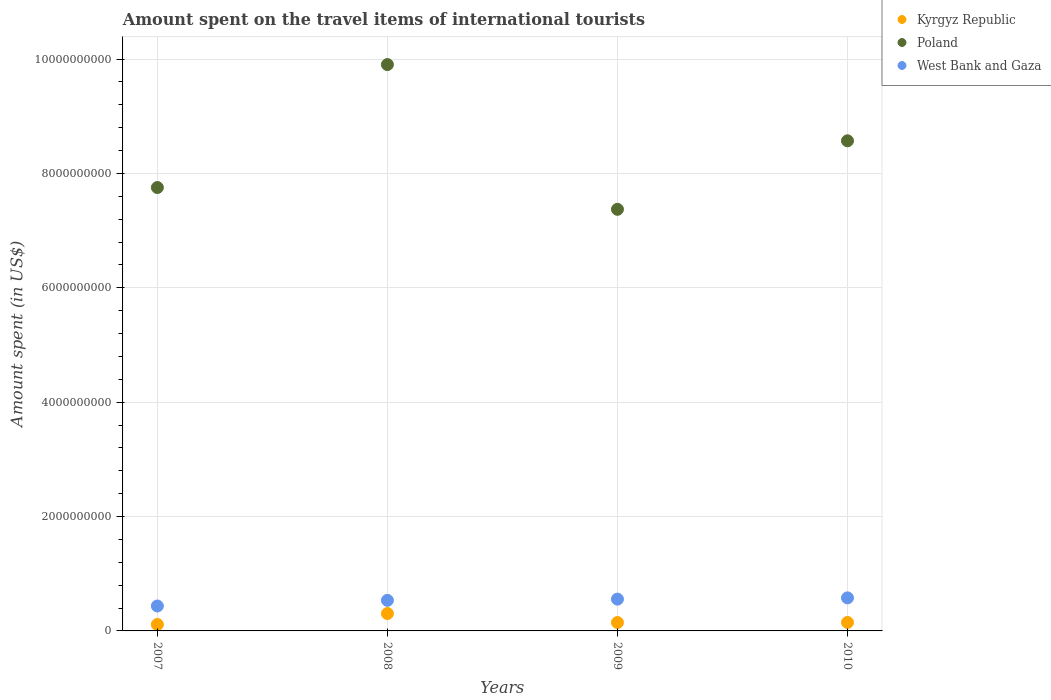How many different coloured dotlines are there?
Offer a terse response. 3. Is the number of dotlines equal to the number of legend labels?
Your answer should be compact. Yes. What is the amount spent on the travel items of international tourists in West Bank and Gaza in 2008?
Offer a terse response. 5.35e+08. Across all years, what is the maximum amount spent on the travel items of international tourists in Kyrgyz Republic?
Give a very brief answer. 3.04e+08. Across all years, what is the minimum amount spent on the travel items of international tourists in West Bank and Gaza?
Keep it short and to the point. 4.36e+08. What is the total amount spent on the travel items of international tourists in Kyrgyz Republic in the graph?
Offer a terse response. 7.11e+08. What is the difference between the amount spent on the travel items of international tourists in Poland in 2009 and that in 2010?
Make the answer very short. -1.20e+09. What is the difference between the amount spent on the travel items of international tourists in Poland in 2008 and the amount spent on the travel items of international tourists in Kyrgyz Republic in 2007?
Your answer should be very brief. 9.79e+09. What is the average amount spent on the travel items of international tourists in Kyrgyz Republic per year?
Your answer should be compact. 1.78e+08. In the year 2009, what is the difference between the amount spent on the travel items of international tourists in West Bank and Gaza and amount spent on the travel items of international tourists in Poland?
Offer a very short reply. -6.82e+09. What is the ratio of the amount spent on the travel items of international tourists in Kyrgyz Republic in 2008 to that in 2010?
Your answer should be very brief. 2.05. Is the difference between the amount spent on the travel items of international tourists in West Bank and Gaza in 2008 and 2010 greater than the difference between the amount spent on the travel items of international tourists in Poland in 2008 and 2010?
Provide a succinct answer. No. What is the difference between the highest and the second highest amount spent on the travel items of international tourists in Poland?
Ensure brevity in your answer.  1.33e+09. What is the difference between the highest and the lowest amount spent on the travel items of international tourists in West Bank and Gaza?
Give a very brief answer. 1.42e+08. Is the amount spent on the travel items of international tourists in Kyrgyz Republic strictly greater than the amount spent on the travel items of international tourists in Poland over the years?
Offer a terse response. No. Is the amount spent on the travel items of international tourists in West Bank and Gaza strictly less than the amount spent on the travel items of international tourists in Kyrgyz Republic over the years?
Provide a succinct answer. No. What is the difference between two consecutive major ticks on the Y-axis?
Provide a short and direct response. 2.00e+09. Does the graph contain grids?
Your answer should be compact. Yes. Where does the legend appear in the graph?
Your answer should be compact. Top right. How many legend labels are there?
Your response must be concise. 3. How are the legend labels stacked?
Offer a terse response. Vertical. What is the title of the graph?
Offer a very short reply. Amount spent on the travel items of international tourists. What is the label or title of the Y-axis?
Ensure brevity in your answer.  Amount spent (in US$). What is the Amount spent (in US$) of Kyrgyz Republic in 2007?
Ensure brevity in your answer.  1.12e+08. What is the Amount spent (in US$) in Poland in 2007?
Your answer should be very brief. 7.75e+09. What is the Amount spent (in US$) of West Bank and Gaza in 2007?
Provide a succinct answer. 4.36e+08. What is the Amount spent (in US$) in Kyrgyz Republic in 2008?
Provide a short and direct response. 3.04e+08. What is the Amount spent (in US$) in Poland in 2008?
Your response must be concise. 9.90e+09. What is the Amount spent (in US$) in West Bank and Gaza in 2008?
Make the answer very short. 5.35e+08. What is the Amount spent (in US$) of Kyrgyz Republic in 2009?
Give a very brief answer. 1.47e+08. What is the Amount spent (in US$) of Poland in 2009?
Ensure brevity in your answer.  7.37e+09. What is the Amount spent (in US$) in West Bank and Gaza in 2009?
Your answer should be compact. 5.56e+08. What is the Amount spent (in US$) in Kyrgyz Republic in 2010?
Your answer should be very brief. 1.48e+08. What is the Amount spent (in US$) in Poland in 2010?
Make the answer very short. 8.57e+09. What is the Amount spent (in US$) of West Bank and Gaza in 2010?
Your response must be concise. 5.78e+08. Across all years, what is the maximum Amount spent (in US$) in Kyrgyz Republic?
Make the answer very short. 3.04e+08. Across all years, what is the maximum Amount spent (in US$) of Poland?
Offer a terse response. 9.90e+09. Across all years, what is the maximum Amount spent (in US$) in West Bank and Gaza?
Your answer should be compact. 5.78e+08. Across all years, what is the minimum Amount spent (in US$) in Kyrgyz Republic?
Ensure brevity in your answer.  1.12e+08. Across all years, what is the minimum Amount spent (in US$) of Poland?
Your answer should be compact. 7.37e+09. Across all years, what is the minimum Amount spent (in US$) of West Bank and Gaza?
Make the answer very short. 4.36e+08. What is the total Amount spent (in US$) in Kyrgyz Republic in the graph?
Give a very brief answer. 7.11e+08. What is the total Amount spent (in US$) in Poland in the graph?
Provide a short and direct response. 3.36e+1. What is the total Amount spent (in US$) of West Bank and Gaza in the graph?
Offer a very short reply. 2.10e+09. What is the difference between the Amount spent (in US$) in Kyrgyz Republic in 2007 and that in 2008?
Ensure brevity in your answer.  -1.92e+08. What is the difference between the Amount spent (in US$) in Poland in 2007 and that in 2008?
Provide a succinct answer. -2.15e+09. What is the difference between the Amount spent (in US$) of West Bank and Gaza in 2007 and that in 2008?
Provide a short and direct response. -9.90e+07. What is the difference between the Amount spent (in US$) in Kyrgyz Republic in 2007 and that in 2009?
Your answer should be very brief. -3.50e+07. What is the difference between the Amount spent (in US$) of Poland in 2007 and that in 2009?
Provide a succinct answer. 3.81e+08. What is the difference between the Amount spent (in US$) of West Bank and Gaza in 2007 and that in 2009?
Offer a terse response. -1.20e+08. What is the difference between the Amount spent (in US$) in Kyrgyz Republic in 2007 and that in 2010?
Ensure brevity in your answer.  -3.60e+07. What is the difference between the Amount spent (in US$) of Poland in 2007 and that in 2010?
Keep it short and to the point. -8.17e+08. What is the difference between the Amount spent (in US$) in West Bank and Gaza in 2007 and that in 2010?
Ensure brevity in your answer.  -1.42e+08. What is the difference between the Amount spent (in US$) of Kyrgyz Republic in 2008 and that in 2009?
Ensure brevity in your answer.  1.57e+08. What is the difference between the Amount spent (in US$) of Poland in 2008 and that in 2009?
Offer a very short reply. 2.53e+09. What is the difference between the Amount spent (in US$) in West Bank and Gaza in 2008 and that in 2009?
Ensure brevity in your answer.  -2.10e+07. What is the difference between the Amount spent (in US$) of Kyrgyz Republic in 2008 and that in 2010?
Keep it short and to the point. 1.56e+08. What is the difference between the Amount spent (in US$) of Poland in 2008 and that in 2010?
Provide a succinct answer. 1.33e+09. What is the difference between the Amount spent (in US$) in West Bank and Gaza in 2008 and that in 2010?
Make the answer very short. -4.30e+07. What is the difference between the Amount spent (in US$) in Poland in 2009 and that in 2010?
Your answer should be compact. -1.20e+09. What is the difference between the Amount spent (in US$) in West Bank and Gaza in 2009 and that in 2010?
Offer a terse response. -2.20e+07. What is the difference between the Amount spent (in US$) of Kyrgyz Republic in 2007 and the Amount spent (in US$) of Poland in 2008?
Offer a terse response. -9.79e+09. What is the difference between the Amount spent (in US$) in Kyrgyz Republic in 2007 and the Amount spent (in US$) in West Bank and Gaza in 2008?
Your answer should be compact. -4.23e+08. What is the difference between the Amount spent (in US$) of Poland in 2007 and the Amount spent (in US$) of West Bank and Gaza in 2008?
Provide a short and direct response. 7.22e+09. What is the difference between the Amount spent (in US$) of Kyrgyz Republic in 2007 and the Amount spent (in US$) of Poland in 2009?
Your response must be concise. -7.26e+09. What is the difference between the Amount spent (in US$) in Kyrgyz Republic in 2007 and the Amount spent (in US$) in West Bank and Gaza in 2009?
Your response must be concise. -4.44e+08. What is the difference between the Amount spent (in US$) of Poland in 2007 and the Amount spent (in US$) of West Bank and Gaza in 2009?
Provide a short and direct response. 7.20e+09. What is the difference between the Amount spent (in US$) in Kyrgyz Republic in 2007 and the Amount spent (in US$) in Poland in 2010?
Ensure brevity in your answer.  -8.46e+09. What is the difference between the Amount spent (in US$) in Kyrgyz Republic in 2007 and the Amount spent (in US$) in West Bank and Gaza in 2010?
Give a very brief answer. -4.66e+08. What is the difference between the Amount spent (in US$) in Poland in 2007 and the Amount spent (in US$) in West Bank and Gaza in 2010?
Offer a very short reply. 7.18e+09. What is the difference between the Amount spent (in US$) in Kyrgyz Republic in 2008 and the Amount spent (in US$) in Poland in 2009?
Make the answer very short. -7.07e+09. What is the difference between the Amount spent (in US$) in Kyrgyz Republic in 2008 and the Amount spent (in US$) in West Bank and Gaza in 2009?
Provide a succinct answer. -2.52e+08. What is the difference between the Amount spent (in US$) of Poland in 2008 and the Amount spent (in US$) of West Bank and Gaza in 2009?
Offer a terse response. 9.35e+09. What is the difference between the Amount spent (in US$) in Kyrgyz Republic in 2008 and the Amount spent (in US$) in Poland in 2010?
Ensure brevity in your answer.  -8.27e+09. What is the difference between the Amount spent (in US$) in Kyrgyz Republic in 2008 and the Amount spent (in US$) in West Bank and Gaza in 2010?
Offer a terse response. -2.74e+08. What is the difference between the Amount spent (in US$) of Poland in 2008 and the Amount spent (in US$) of West Bank and Gaza in 2010?
Provide a short and direct response. 9.32e+09. What is the difference between the Amount spent (in US$) in Kyrgyz Republic in 2009 and the Amount spent (in US$) in Poland in 2010?
Offer a very short reply. -8.42e+09. What is the difference between the Amount spent (in US$) of Kyrgyz Republic in 2009 and the Amount spent (in US$) of West Bank and Gaza in 2010?
Provide a succinct answer. -4.31e+08. What is the difference between the Amount spent (in US$) of Poland in 2009 and the Amount spent (in US$) of West Bank and Gaza in 2010?
Give a very brief answer. 6.79e+09. What is the average Amount spent (in US$) of Kyrgyz Republic per year?
Provide a short and direct response. 1.78e+08. What is the average Amount spent (in US$) in Poland per year?
Make the answer very short. 8.40e+09. What is the average Amount spent (in US$) of West Bank and Gaza per year?
Provide a succinct answer. 5.26e+08. In the year 2007, what is the difference between the Amount spent (in US$) in Kyrgyz Republic and Amount spent (in US$) in Poland?
Offer a very short reply. -7.64e+09. In the year 2007, what is the difference between the Amount spent (in US$) of Kyrgyz Republic and Amount spent (in US$) of West Bank and Gaza?
Offer a very short reply. -3.24e+08. In the year 2007, what is the difference between the Amount spent (in US$) in Poland and Amount spent (in US$) in West Bank and Gaza?
Your response must be concise. 7.32e+09. In the year 2008, what is the difference between the Amount spent (in US$) in Kyrgyz Republic and Amount spent (in US$) in Poland?
Offer a terse response. -9.60e+09. In the year 2008, what is the difference between the Amount spent (in US$) in Kyrgyz Republic and Amount spent (in US$) in West Bank and Gaza?
Make the answer very short. -2.31e+08. In the year 2008, what is the difference between the Amount spent (in US$) of Poland and Amount spent (in US$) of West Bank and Gaza?
Offer a terse response. 9.37e+09. In the year 2009, what is the difference between the Amount spent (in US$) of Kyrgyz Republic and Amount spent (in US$) of Poland?
Provide a short and direct response. -7.22e+09. In the year 2009, what is the difference between the Amount spent (in US$) in Kyrgyz Republic and Amount spent (in US$) in West Bank and Gaza?
Give a very brief answer. -4.09e+08. In the year 2009, what is the difference between the Amount spent (in US$) in Poland and Amount spent (in US$) in West Bank and Gaza?
Your response must be concise. 6.82e+09. In the year 2010, what is the difference between the Amount spent (in US$) of Kyrgyz Republic and Amount spent (in US$) of Poland?
Offer a terse response. -8.42e+09. In the year 2010, what is the difference between the Amount spent (in US$) of Kyrgyz Republic and Amount spent (in US$) of West Bank and Gaza?
Make the answer very short. -4.30e+08. In the year 2010, what is the difference between the Amount spent (in US$) in Poland and Amount spent (in US$) in West Bank and Gaza?
Provide a succinct answer. 7.99e+09. What is the ratio of the Amount spent (in US$) of Kyrgyz Republic in 2007 to that in 2008?
Offer a terse response. 0.37. What is the ratio of the Amount spent (in US$) of Poland in 2007 to that in 2008?
Give a very brief answer. 0.78. What is the ratio of the Amount spent (in US$) in West Bank and Gaza in 2007 to that in 2008?
Keep it short and to the point. 0.81. What is the ratio of the Amount spent (in US$) of Kyrgyz Republic in 2007 to that in 2009?
Your answer should be compact. 0.76. What is the ratio of the Amount spent (in US$) in Poland in 2007 to that in 2009?
Give a very brief answer. 1.05. What is the ratio of the Amount spent (in US$) of West Bank and Gaza in 2007 to that in 2009?
Provide a short and direct response. 0.78. What is the ratio of the Amount spent (in US$) in Kyrgyz Republic in 2007 to that in 2010?
Keep it short and to the point. 0.76. What is the ratio of the Amount spent (in US$) of Poland in 2007 to that in 2010?
Offer a very short reply. 0.9. What is the ratio of the Amount spent (in US$) of West Bank and Gaza in 2007 to that in 2010?
Offer a very short reply. 0.75. What is the ratio of the Amount spent (in US$) of Kyrgyz Republic in 2008 to that in 2009?
Keep it short and to the point. 2.07. What is the ratio of the Amount spent (in US$) in Poland in 2008 to that in 2009?
Provide a succinct answer. 1.34. What is the ratio of the Amount spent (in US$) in West Bank and Gaza in 2008 to that in 2009?
Your response must be concise. 0.96. What is the ratio of the Amount spent (in US$) of Kyrgyz Republic in 2008 to that in 2010?
Provide a succinct answer. 2.05. What is the ratio of the Amount spent (in US$) in Poland in 2008 to that in 2010?
Provide a succinct answer. 1.16. What is the ratio of the Amount spent (in US$) in West Bank and Gaza in 2008 to that in 2010?
Offer a very short reply. 0.93. What is the ratio of the Amount spent (in US$) of Kyrgyz Republic in 2009 to that in 2010?
Ensure brevity in your answer.  0.99. What is the ratio of the Amount spent (in US$) in Poland in 2009 to that in 2010?
Your response must be concise. 0.86. What is the ratio of the Amount spent (in US$) in West Bank and Gaza in 2009 to that in 2010?
Offer a terse response. 0.96. What is the difference between the highest and the second highest Amount spent (in US$) of Kyrgyz Republic?
Your answer should be very brief. 1.56e+08. What is the difference between the highest and the second highest Amount spent (in US$) of Poland?
Your response must be concise. 1.33e+09. What is the difference between the highest and the second highest Amount spent (in US$) of West Bank and Gaza?
Provide a succinct answer. 2.20e+07. What is the difference between the highest and the lowest Amount spent (in US$) of Kyrgyz Republic?
Make the answer very short. 1.92e+08. What is the difference between the highest and the lowest Amount spent (in US$) of Poland?
Offer a very short reply. 2.53e+09. What is the difference between the highest and the lowest Amount spent (in US$) of West Bank and Gaza?
Provide a short and direct response. 1.42e+08. 